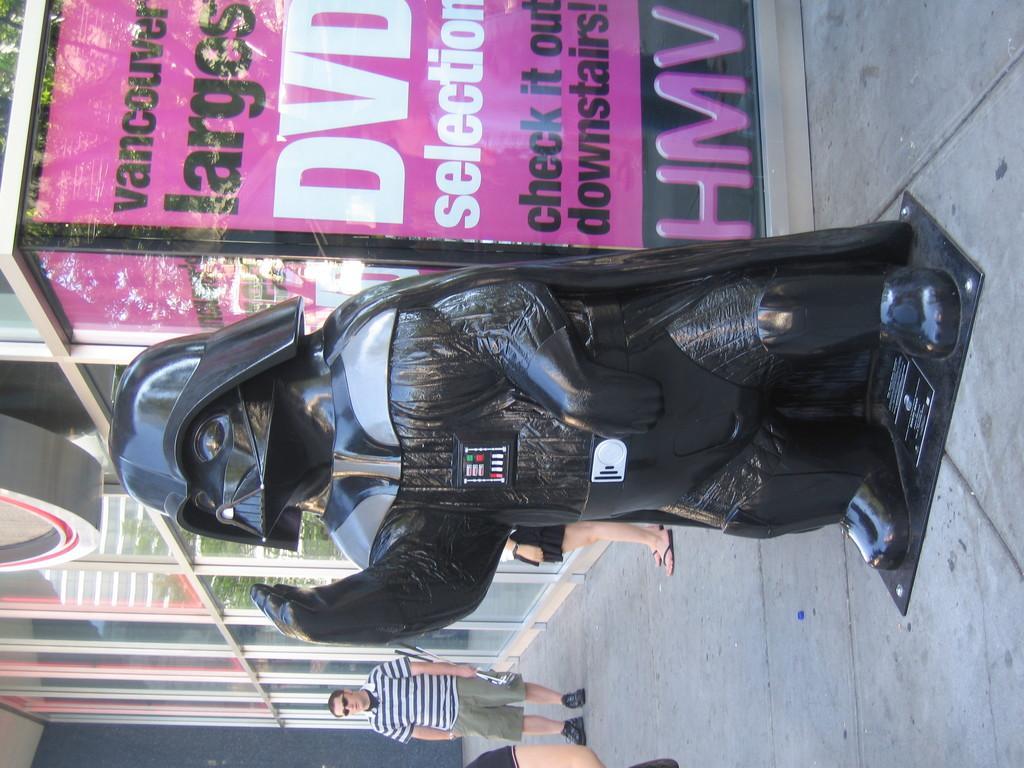In one or two sentences, can you explain what this image depicts? In this image there are people, there is a sculpture, there is a floor, poster and glass doors. 